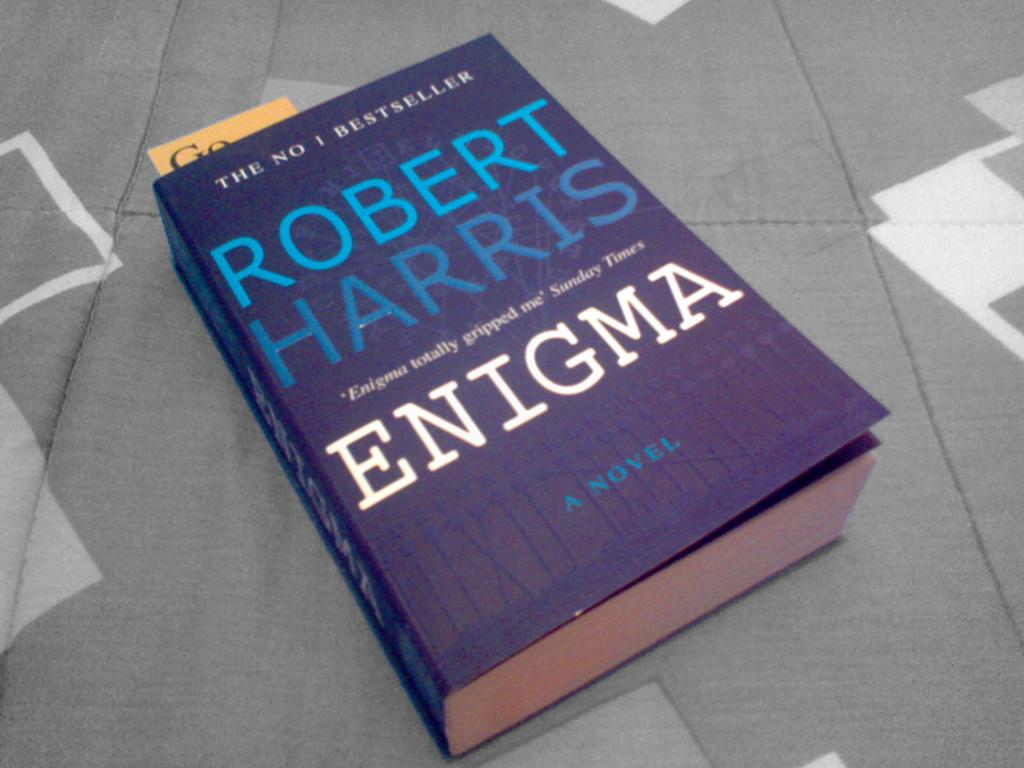Who wrote the book?
Make the answer very short. Robert harris. 